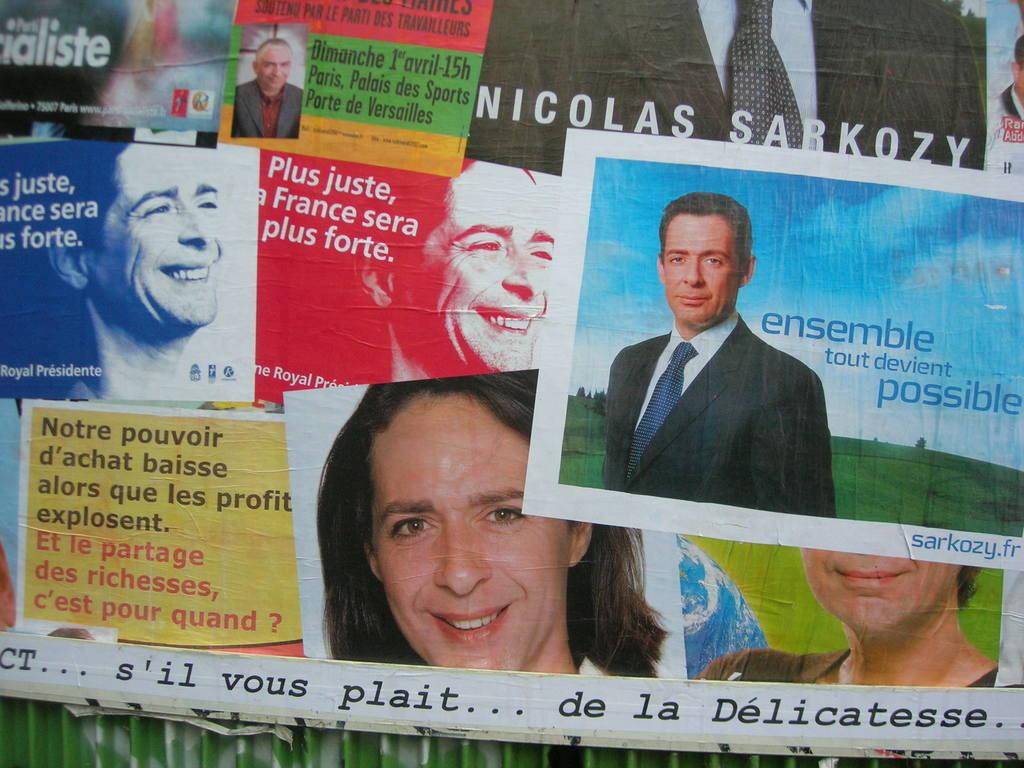What is the main subject of the image? The main subject of the image is posters featuring people wearing clothes. Can you describe the expressions of the people in the posters? Some of the people in the posters are smiling. Are there any other elements in the image besides the posters? If the text is part of the image, then there is a text in the image. What type of apparel is being destroyed by the bit in the image? There is no apparel or bit present in the image. How does the destruction of the clothes affect the people in the posters? There is no destruction of clothes or people present in the image. 